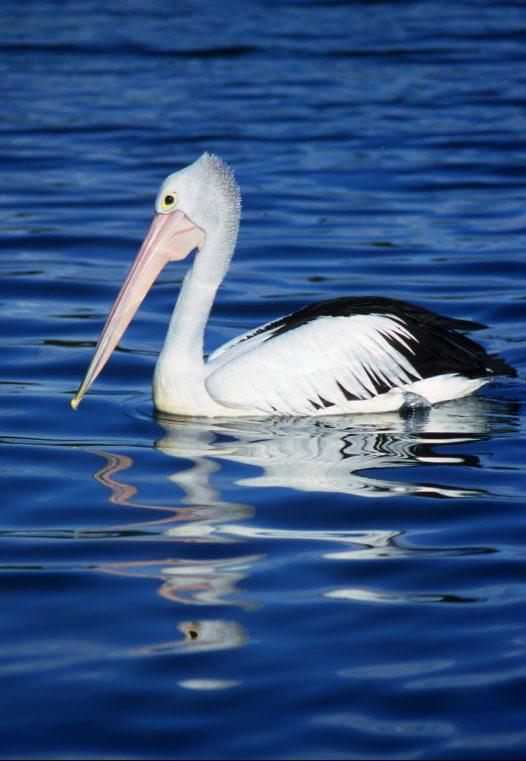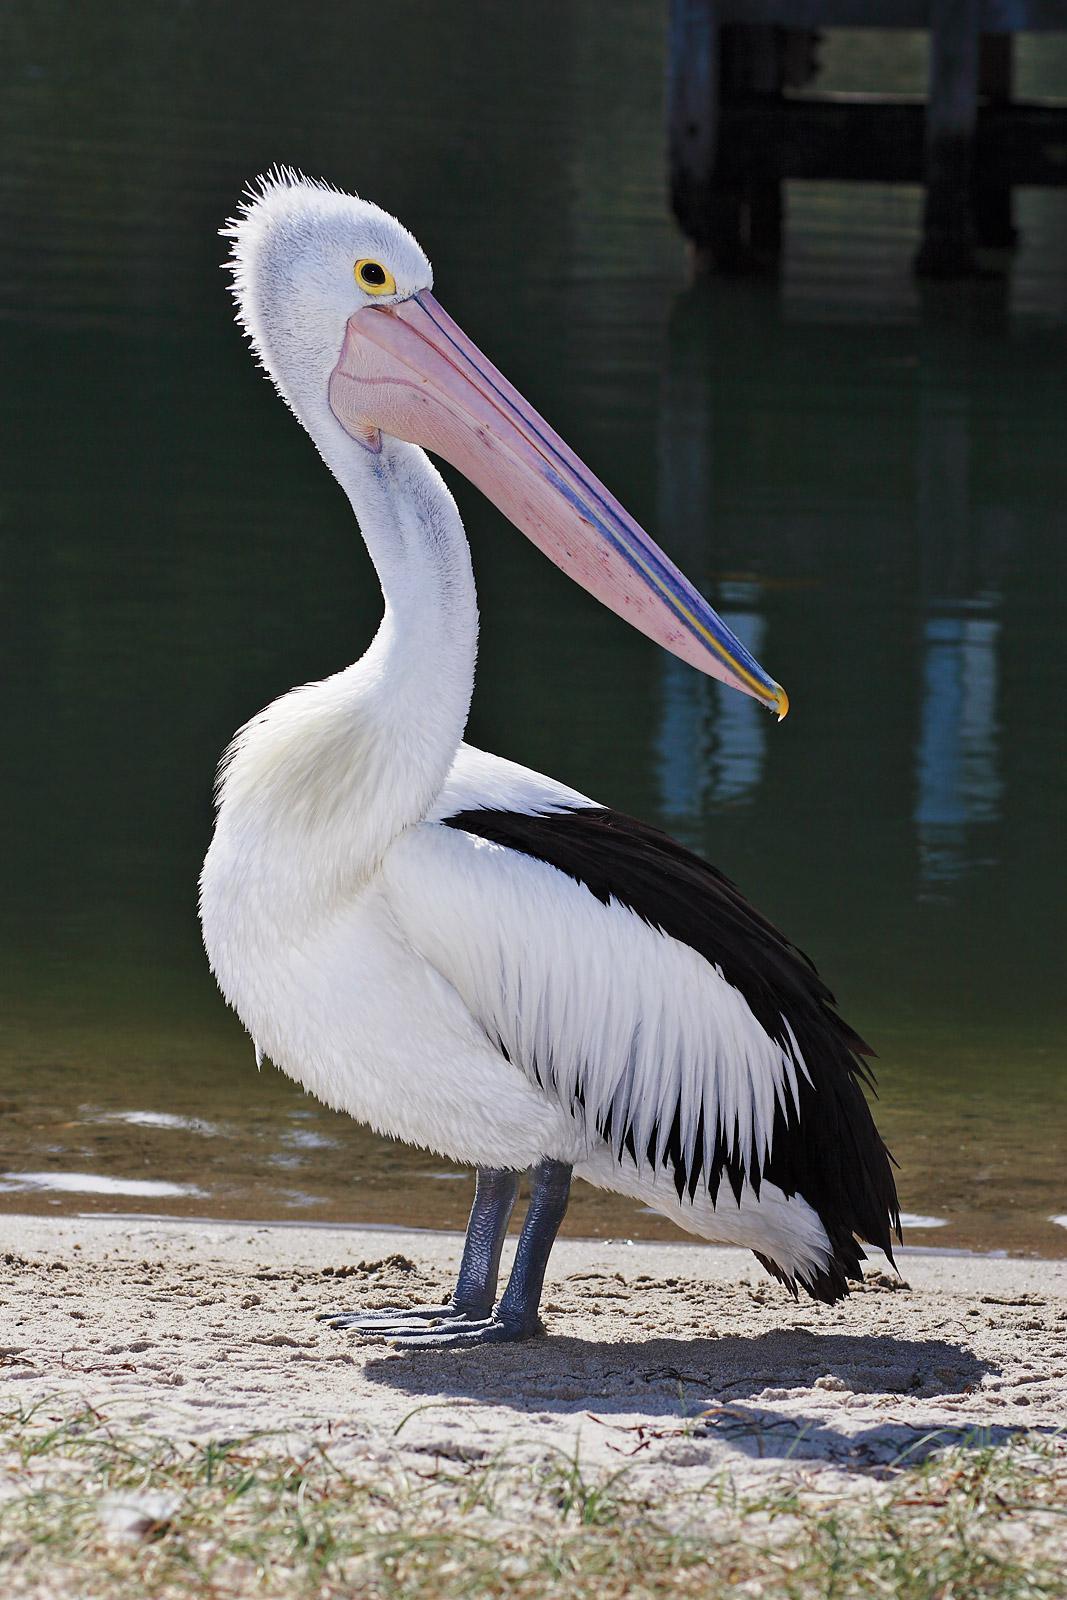The first image is the image on the left, the second image is the image on the right. Assess this claim about the two images: "There is a pelican flying in the air.". Correct or not? Answer yes or no. No. 